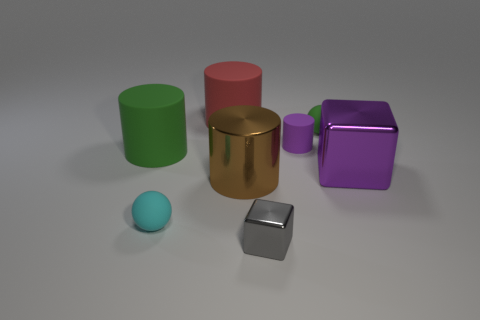Add 1 large cyan cylinders. How many objects exist? 9 Add 5 purple blocks. How many purple blocks are left? 6 Add 7 gray cylinders. How many gray cylinders exist? 7 Subtract all purple cylinders. How many cylinders are left? 3 Subtract all matte cylinders. How many cylinders are left? 1 Subtract 0 red spheres. How many objects are left? 8 Subtract all balls. How many objects are left? 6 Subtract 1 blocks. How many blocks are left? 1 Subtract all red cylinders. Subtract all red balls. How many cylinders are left? 3 Subtract all yellow blocks. How many green balls are left? 1 